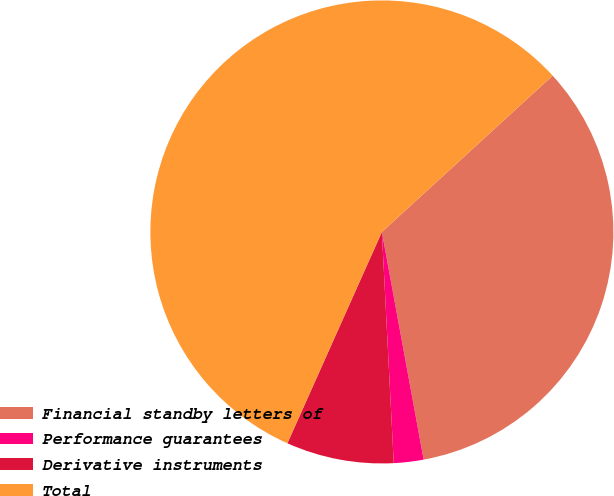<chart> <loc_0><loc_0><loc_500><loc_500><pie_chart><fcel>Financial standby letters of<fcel>Performance guarantees<fcel>Derivative instruments<fcel>Total<nl><fcel>33.91%<fcel>2.07%<fcel>7.51%<fcel>56.51%<nl></chart> 